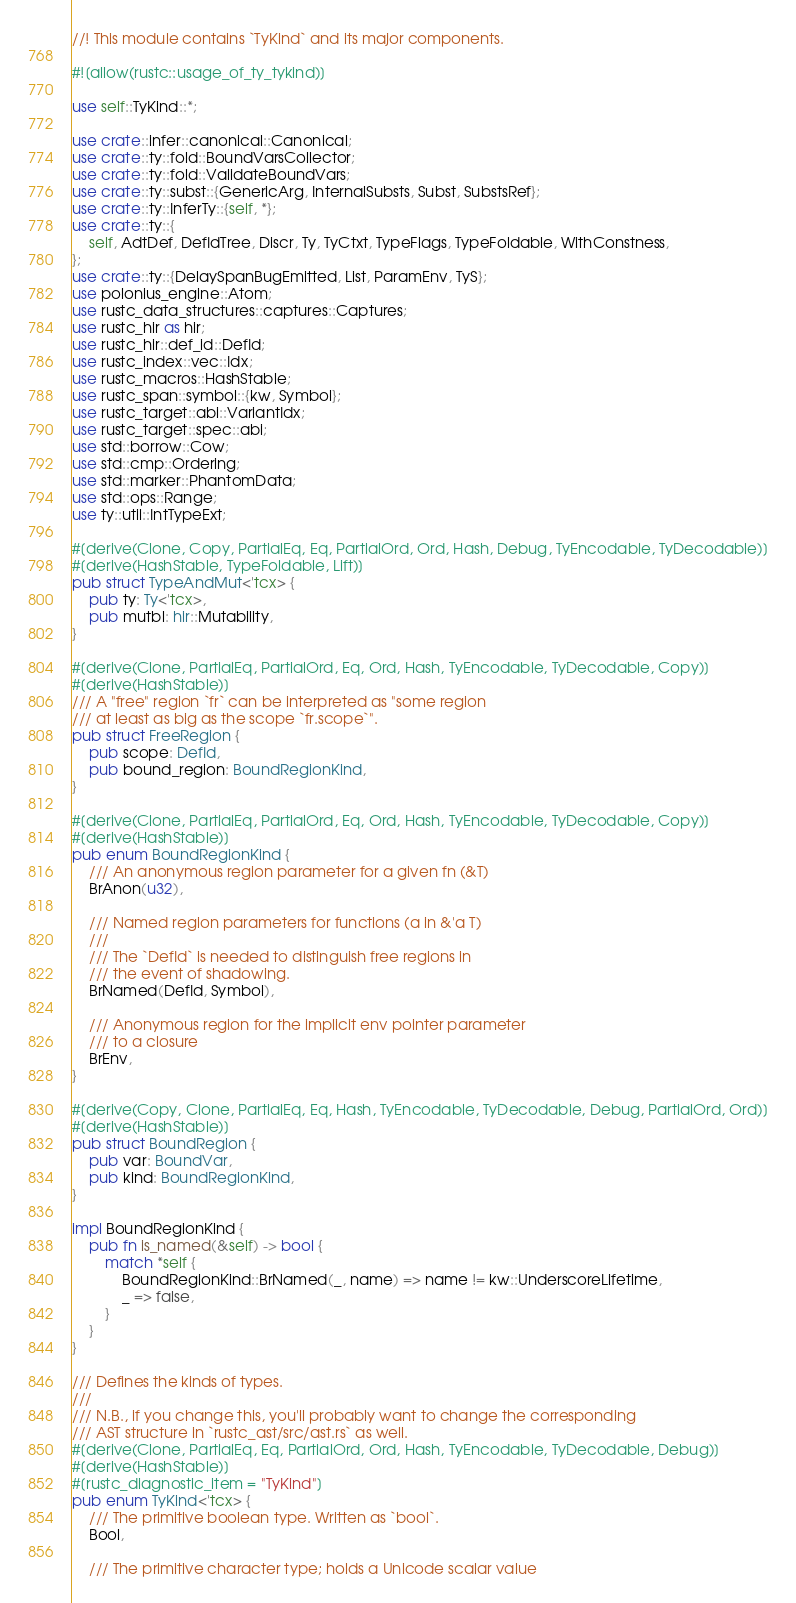<code> <loc_0><loc_0><loc_500><loc_500><_Rust_>//! This module contains `TyKind` and its major components.

#![allow(rustc::usage_of_ty_tykind)]

use self::TyKind::*;

use crate::infer::canonical::Canonical;
use crate::ty::fold::BoundVarsCollector;
use crate::ty::fold::ValidateBoundVars;
use crate::ty::subst::{GenericArg, InternalSubsts, Subst, SubstsRef};
use crate::ty::InferTy::{self, *};
use crate::ty::{
    self, AdtDef, DefIdTree, Discr, Ty, TyCtxt, TypeFlags, TypeFoldable, WithConstness,
};
use crate::ty::{DelaySpanBugEmitted, List, ParamEnv, TyS};
use polonius_engine::Atom;
use rustc_data_structures::captures::Captures;
use rustc_hir as hir;
use rustc_hir::def_id::DefId;
use rustc_index::vec::Idx;
use rustc_macros::HashStable;
use rustc_span::symbol::{kw, Symbol};
use rustc_target::abi::VariantIdx;
use rustc_target::spec::abi;
use std::borrow::Cow;
use std::cmp::Ordering;
use std::marker::PhantomData;
use std::ops::Range;
use ty::util::IntTypeExt;

#[derive(Clone, Copy, PartialEq, Eq, PartialOrd, Ord, Hash, Debug, TyEncodable, TyDecodable)]
#[derive(HashStable, TypeFoldable, Lift)]
pub struct TypeAndMut<'tcx> {
    pub ty: Ty<'tcx>,
    pub mutbl: hir::Mutability,
}

#[derive(Clone, PartialEq, PartialOrd, Eq, Ord, Hash, TyEncodable, TyDecodable, Copy)]
#[derive(HashStable)]
/// A "free" region `fr` can be interpreted as "some region
/// at least as big as the scope `fr.scope`".
pub struct FreeRegion {
    pub scope: DefId,
    pub bound_region: BoundRegionKind,
}

#[derive(Clone, PartialEq, PartialOrd, Eq, Ord, Hash, TyEncodable, TyDecodable, Copy)]
#[derive(HashStable)]
pub enum BoundRegionKind {
    /// An anonymous region parameter for a given fn (&T)
    BrAnon(u32),

    /// Named region parameters for functions (a in &'a T)
    ///
    /// The `DefId` is needed to distinguish free regions in
    /// the event of shadowing.
    BrNamed(DefId, Symbol),

    /// Anonymous region for the implicit env pointer parameter
    /// to a closure
    BrEnv,
}

#[derive(Copy, Clone, PartialEq, Eq, Hash, TyEncodable, TyDecodable, Debug, PartialOrd, Ord)]
#[derive(HashStable)]
pub struct BoundRegion {
    pub var: BoundVar,
    pub kind: BoundRegionKind,
}

impl BoundRegionKind {
    pub fn is_named(&self) -> bool {
        match *self {
            BoundRegionKind::BrNamed(_, name) => name != kw::UnderscoreLifetime,
            _ => false,
        }
    }
}

/// Defines the kinds of types.
///
/// N.B., if you change this, you'll probably want to change the corresponding
/// AST structure in `rustc_ast/src/ast.rs` as well.
#[derive(Clone, PartialEq, Eq, PartialOrd, Ord, Hash, TyEncodable, TyDecodable, Debug)]
#[derive(HashStable)]
#[rustc_diagnostic_item = "TyKind"]
pub enum TyKind<'tcx> {
    /// The primitive boolean type. Written as `bool`.
    Bool,

    /// The primitive character type; holds a Unicode scalar value</code> 